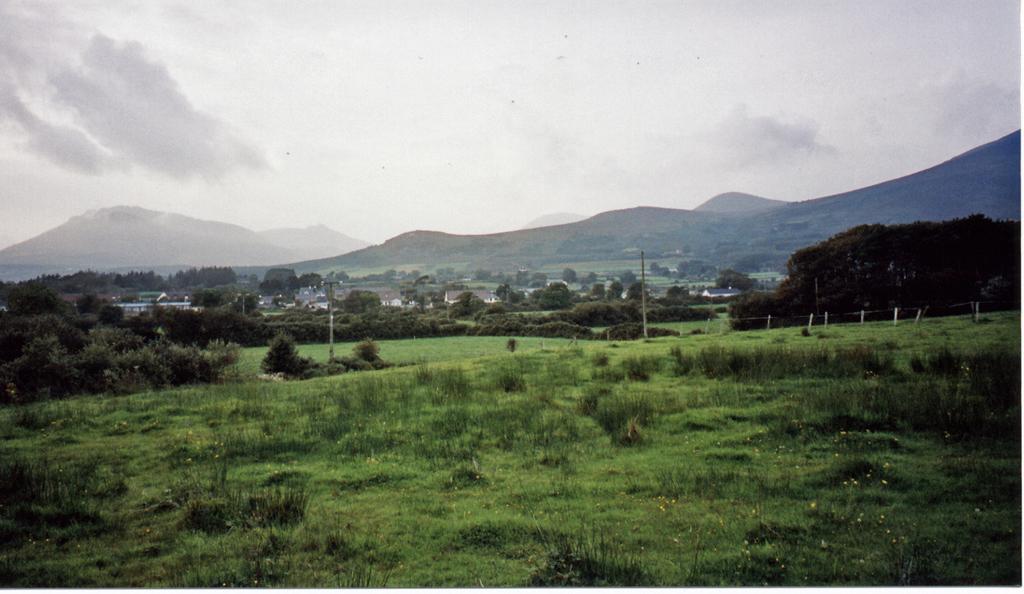Could you give a brief overview of what you see in this image? This is an outside view. At the bottom of the image I can see the grass and plants. In the background there are many trees, buildings and also I can see the hills. At the top I can see the sky. 